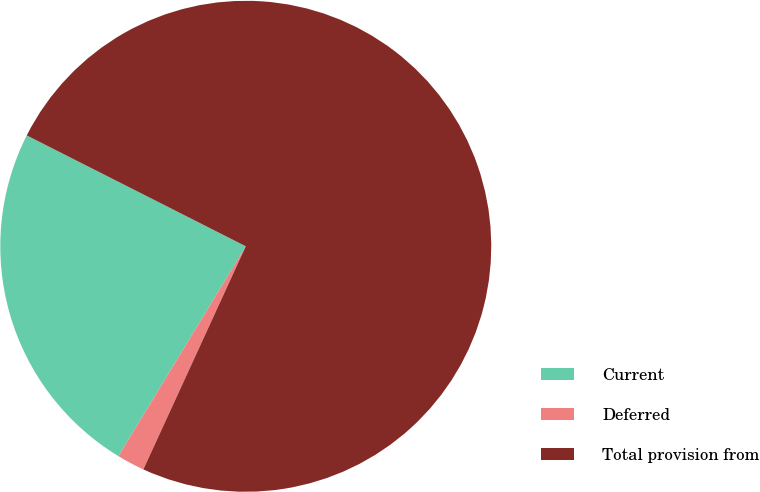<chart> <loc_0><loc_0><loc_500><loc_500><pie_chart><fcel>Current<fcel>Deferred<fcel>Total provision from<nl><fcel>23.78%<fcel>1.83%<fcel>74.39%<nl></chart> 